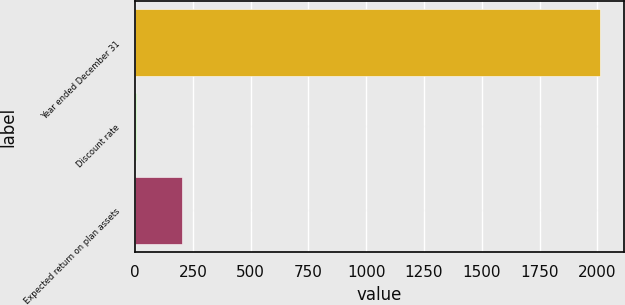<chart> <loc_0><loc_0><loc_500><loc_500><bar_chart><fcel>Year ended December 31<fcel>Discount rate<fcel>Expected return on plan assets<nl><fcel>2013<fcel>3.5<fcel>204.45<nl></chart> 